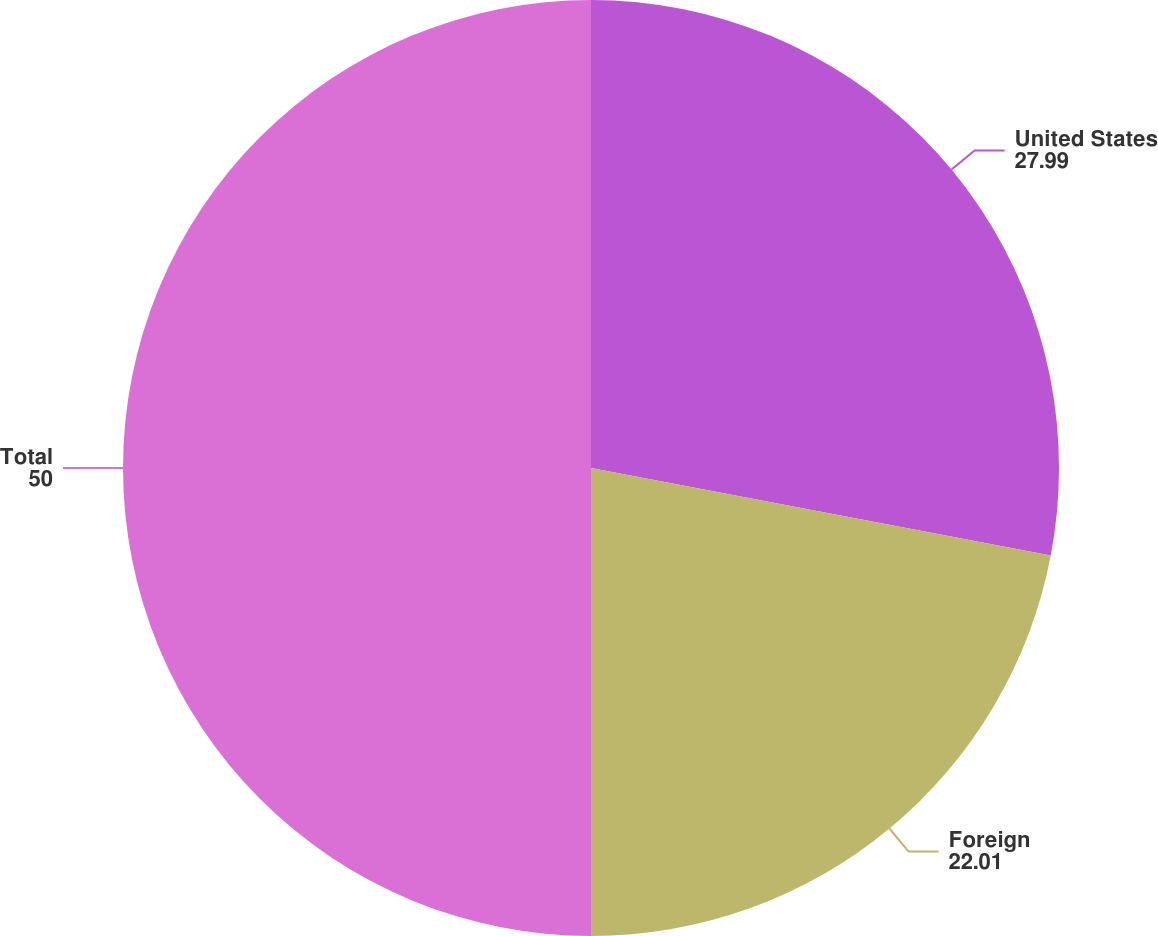Convert chart. <chart><loc_0><loc_0><loc_500><loc_500><pie_chart><fcel>United States<fcel>Foreign<fcel>Total<nl><fcel>27.99%<fcel>22.01%<fcel>50.0%<nl></chart> 